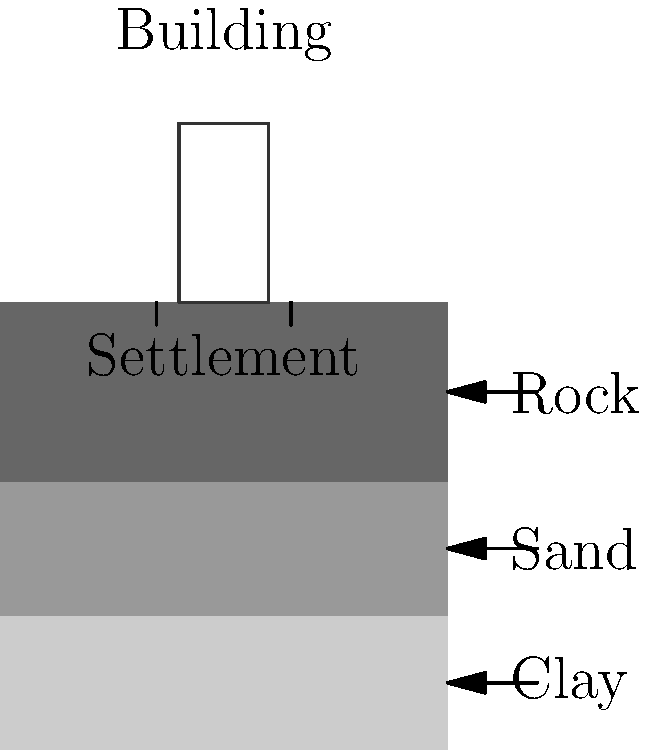A 5-story building is constructed on a layered soil profile consisting of clay (10m thick), sand (10m thick), and bedrock. The building exerts a pressure of 200 kPa on the foundation. Given that the clay layer has a compression index ($C_c$) of 0.2, an initial void ratio ($e_0$) of 0.9, and is normally consolidated, calculate the total settlement of the building. Assume the effective overburden pressure ($p_0'$) at the middle of the clay layer is 75 kPa. To calculate the settlement of the building, we'll use the consolidation settlement equation for normally consolidated clay:

$$ S = H \frac{C_c}{1+e_0} \log_{10}\left(\frac{p_0' + \Delta p}{p_0'}\right) $$

Where:
$S$ = Settlement
$H$ = Thickness of the clay layer
$C_c$ = Compression index
$e_0$ = Initial void ratio
$p_0'$ = Effective overburden pressure
$\Delta p$ = Change in pressure due to the building

Step 1: Identify the given values
- $H = 10$ m
- $C_c = 0.2$
- $e_0 = 0.9$
- $p_0' = 75$ kPa
- $\Delta p = 200$ kPa

Step 2: Substitute the values into the equation
$$ S = 10 \frac{0.2}{1+0.9} \log_{10}\left(\frac{75 + 200}{75}\right) $$

Step 3: Simplify and calculate
$$ S = 10 \cdot \frac{0.2}{1.9} \log_{10}(3.67) $$
$$ S = 1.05 \cdot 0.56 $$
$$ S = 0.59 \text{ m} $$

Therefore, the total settlement of the building is approximately 0.59 meters or 59 cm.
Answer: 0.59 m 